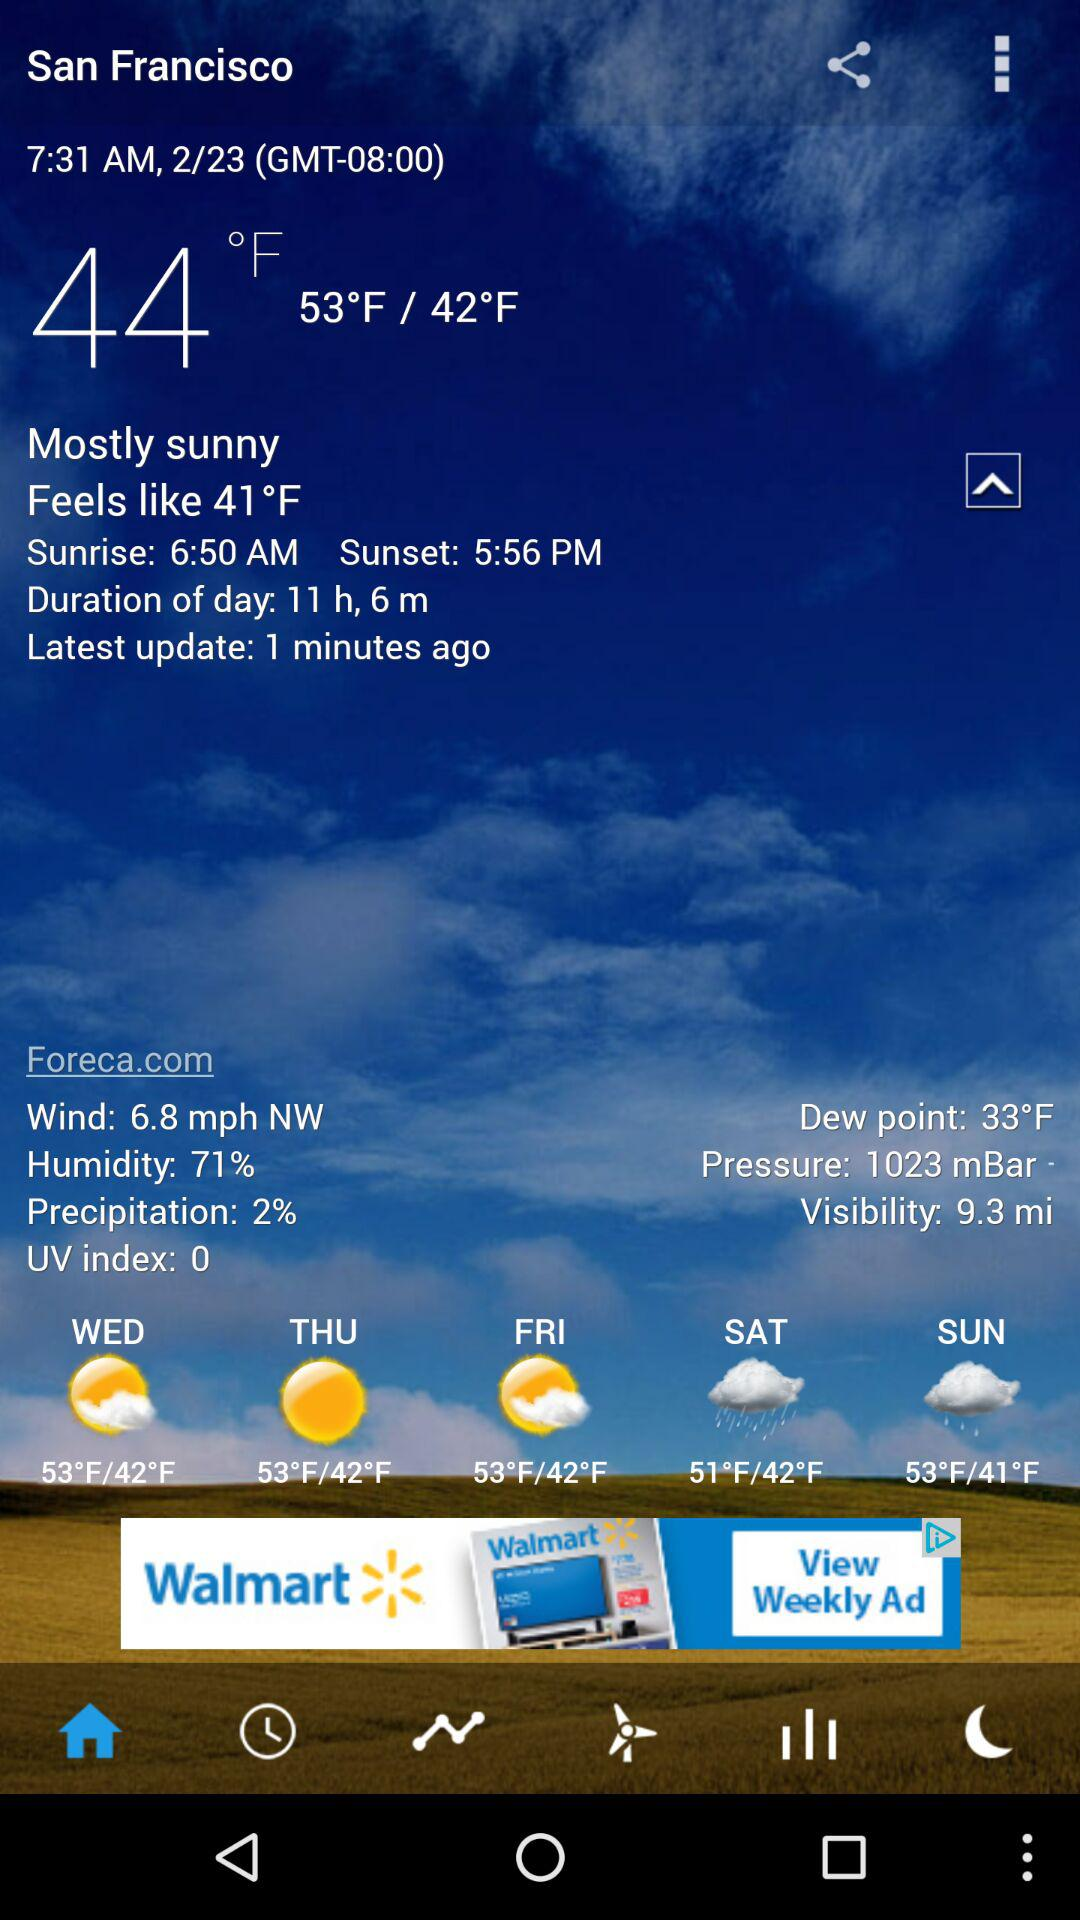When was it last updated? It was last updated 1 minute ago. 